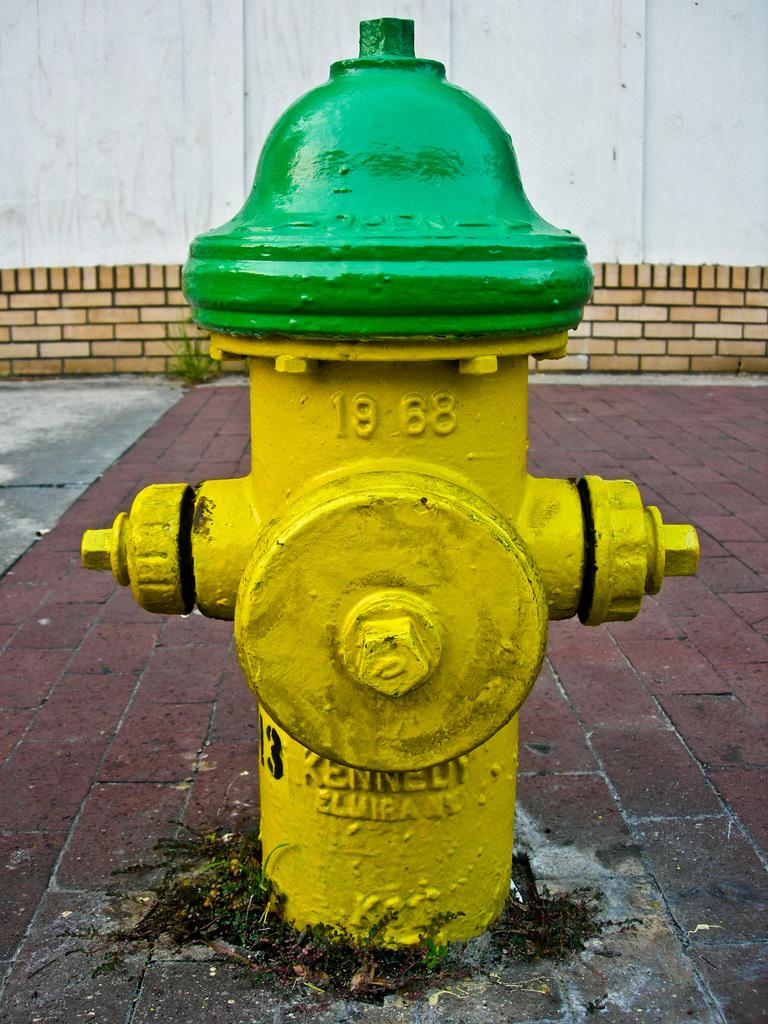What object is located on the ground in the image? There is a hydrant on the ground in the image. What can be seen in the background of the image? There is a wall in the background of the image. What type of sheet is being used for learning purposes in the image? There is no sheet present in the image, nor is there any indication of learning activities taking place. 